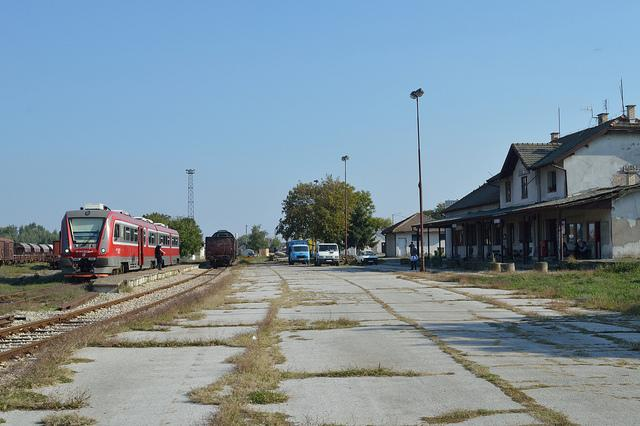What is the old rusted freight car in the background probably used to carry? coal 